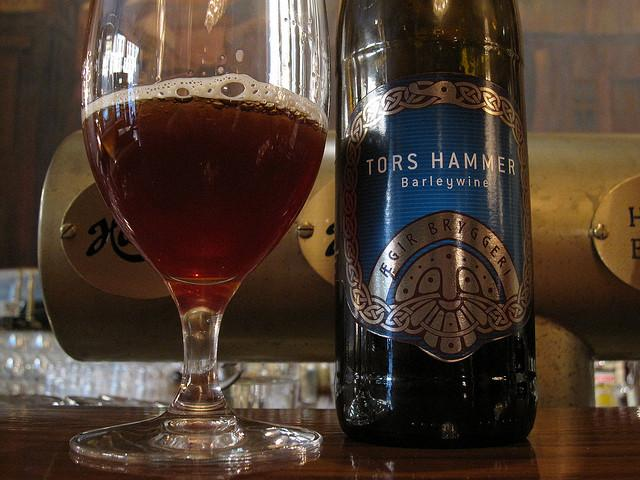The bottle is related to what group of people? vikings 